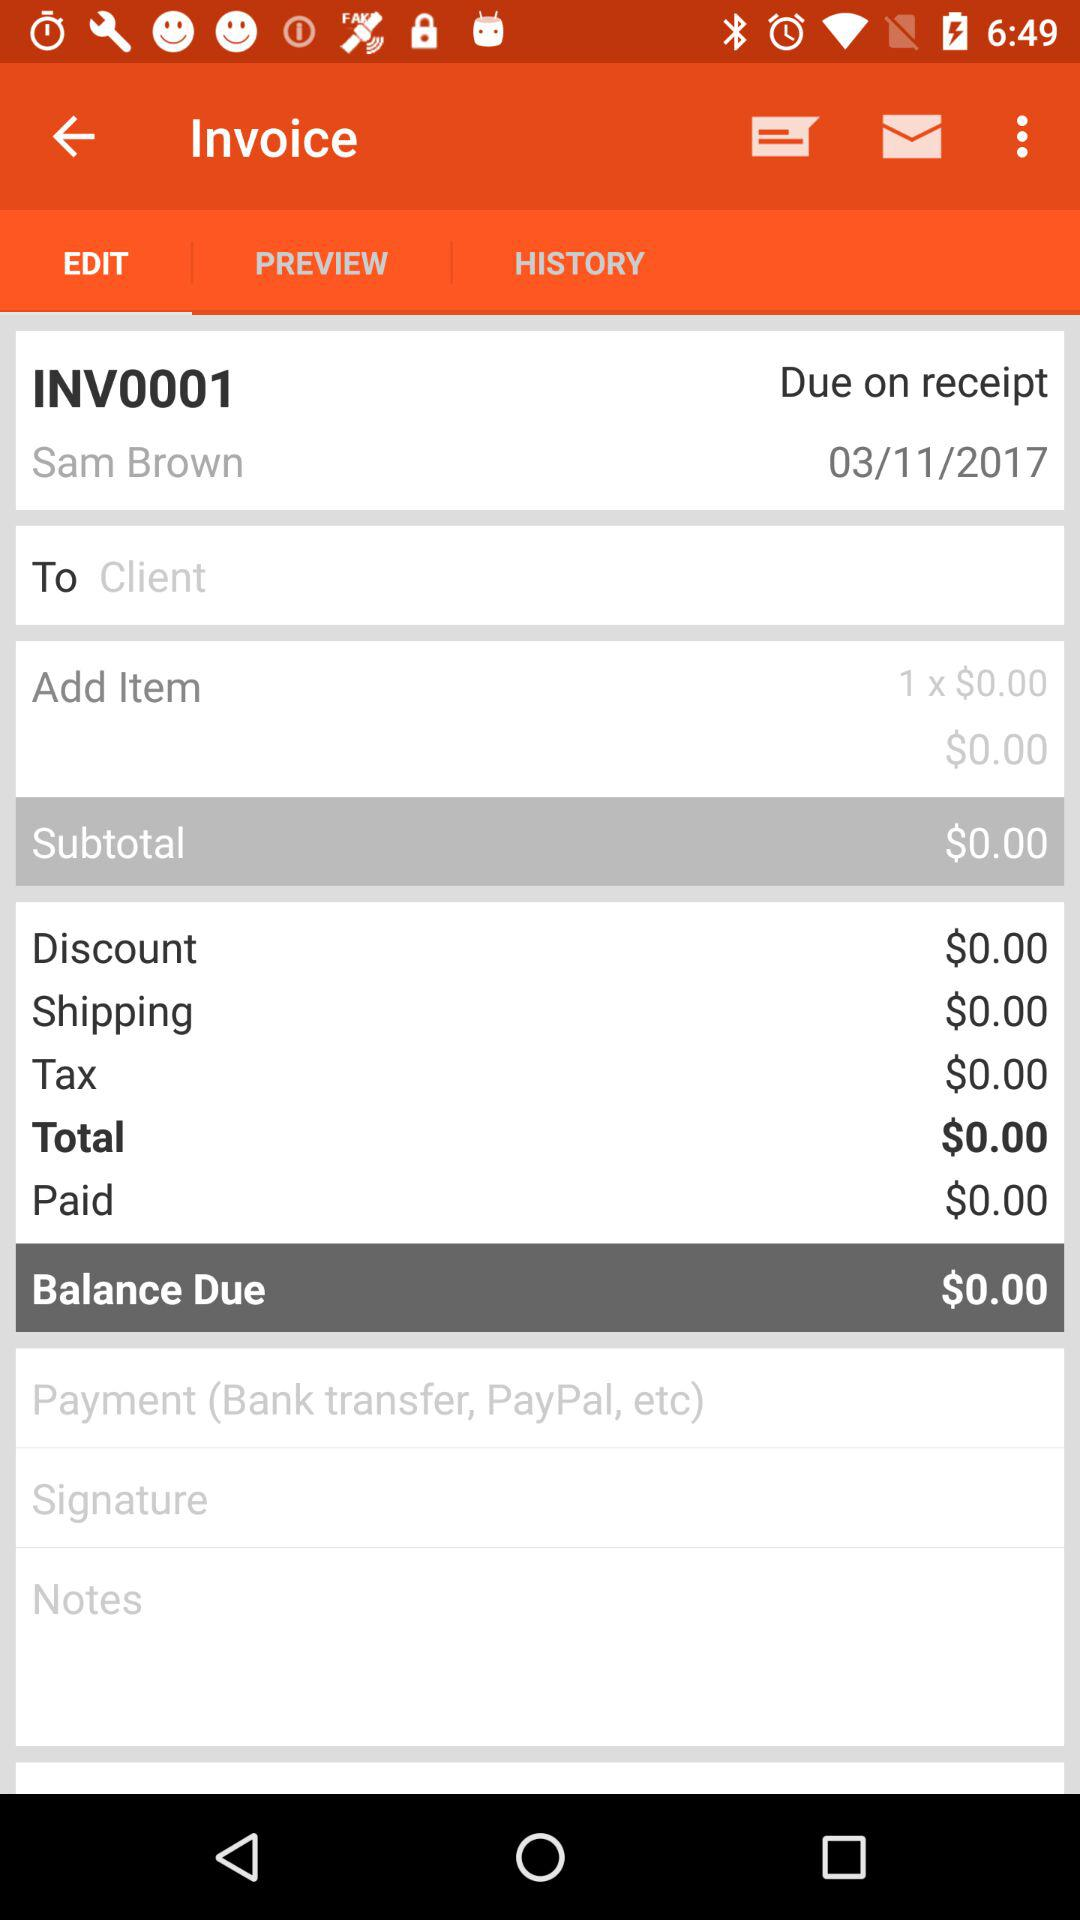What is the due date for the receipt? The due date is March 11, 2017. 